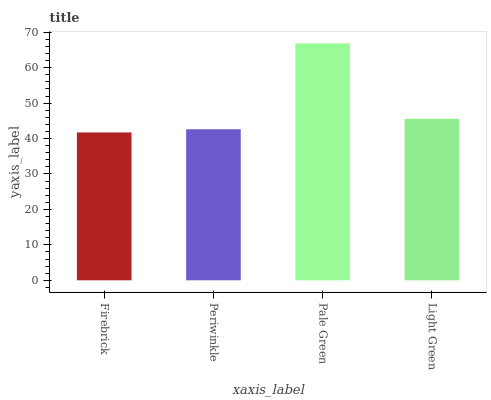Is Periwinkle the minimum?
Answer yes or no. No. Is Periwinkle the maximum?
Answer yes or no. No. Is Periwinkle greater than Firebrick?
Answer yes or no. Yes. Is Firebrick less than Periwinkle?
Answer yes or no. Yes. Is Firebrick greater than Periwinkle?
Answer yes or no. No. Is Periwinkle less than Firebrick?
Answer yes or no. No. Is Light Green the high median?
Answer yes or no. Yes. Is Periwinkle the low median?
Answer yes or no. Yes. Is Firebrick the high median?
Answer yes or no. No. Is Light Green the low median?
Answer yes or no. No. 